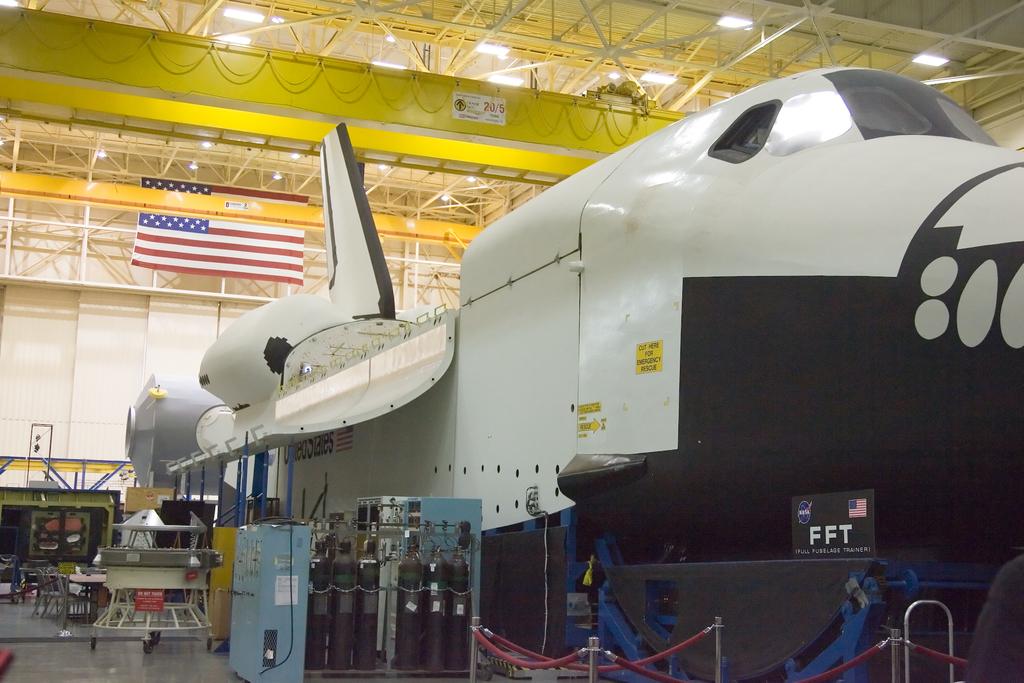What does fft stand for?
Give a very brief answer. Full fuselage trainer. What does the logo next to fft say?
Offer a very short reply. Nasa. 